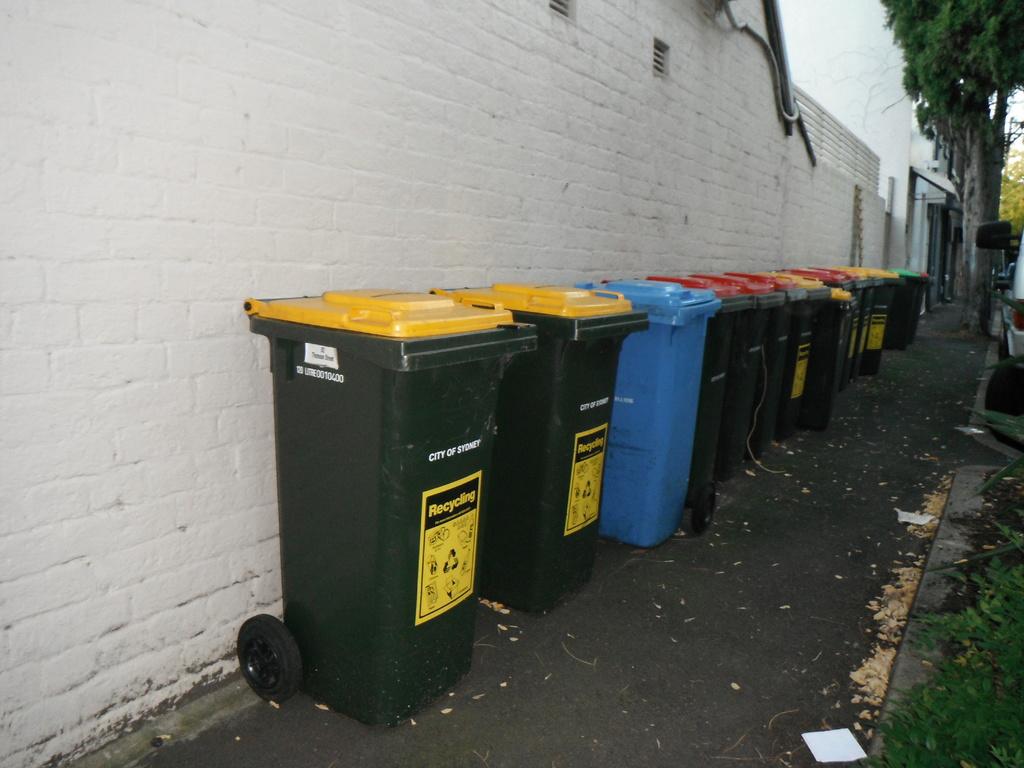What company picks up the trash?
Your answer should be compact. Unanswerable. What is the green and yellow bin for as seen on the front of the can?
Offer a terse response. Recycling. 